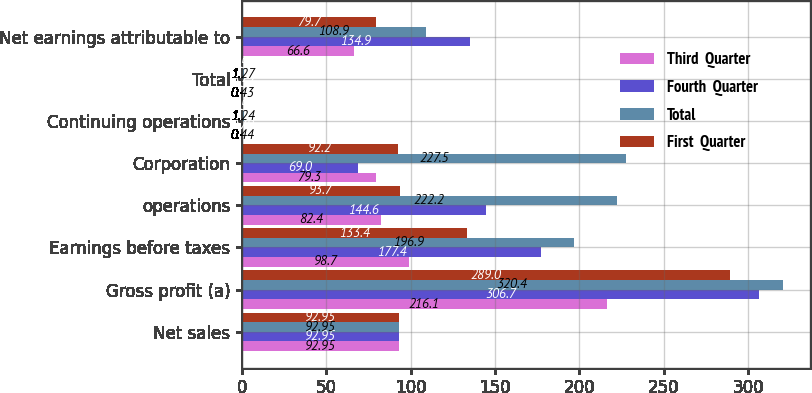<chart> <loc_0><loc_0><loc_500><loc_500><stacked_bar_chart><ecel><fcel>Net sales<fcel>Gross profit (a)<fcel>Earnings before taxes<fcel>operations<fcel>Corporation<fcel>Continuing operations<fcel>Total<fcel>Net earnings attributable to<nl><fcel>Third  Quarter<fcel>92.95<fcel>216.1<fcel>98.7<fcel>82.4<fcel>79.3<fcel>0.44<fcel>0.43<fcel>66.6<nl><fcel>Fourth  Quarter<fcel>92.95<fcel>306.7<fcel>177.4<fcel>144.6<fcel>69<fcel>0.79<fcel>0.37<fcel>134.9<nl><fcel>Total<fcel>92.95<fcel>320.4<fcel>196.9<fcel>222.2<fcel>227.5<fcel>1.24<fcel>1.27<fcel>108.9<nl><fcel>First  Quarter<fcel>92.95<fcel>289<fcel>133.4<fcel>93.7<fcel>92.2<fcel>0.54<fcel>0.53<fcel>79.7<nl></chart> 